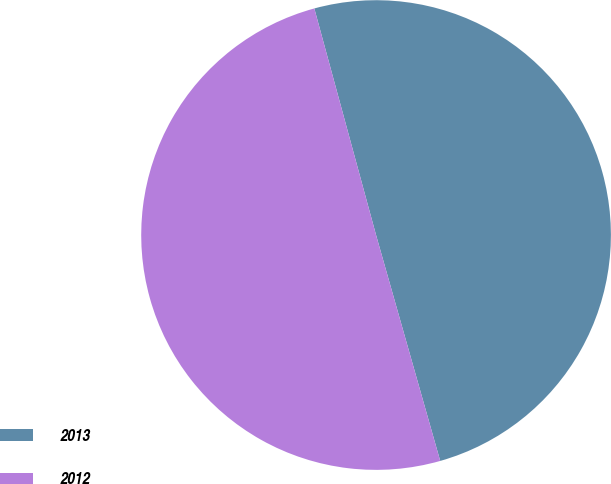<chart> <loc_0><loc_0><loc_500><loc_500><pie_chart><fcel>2013<fcel>2012<nl><fcel>49.83%<fcel>50.17%<nl></chart> 